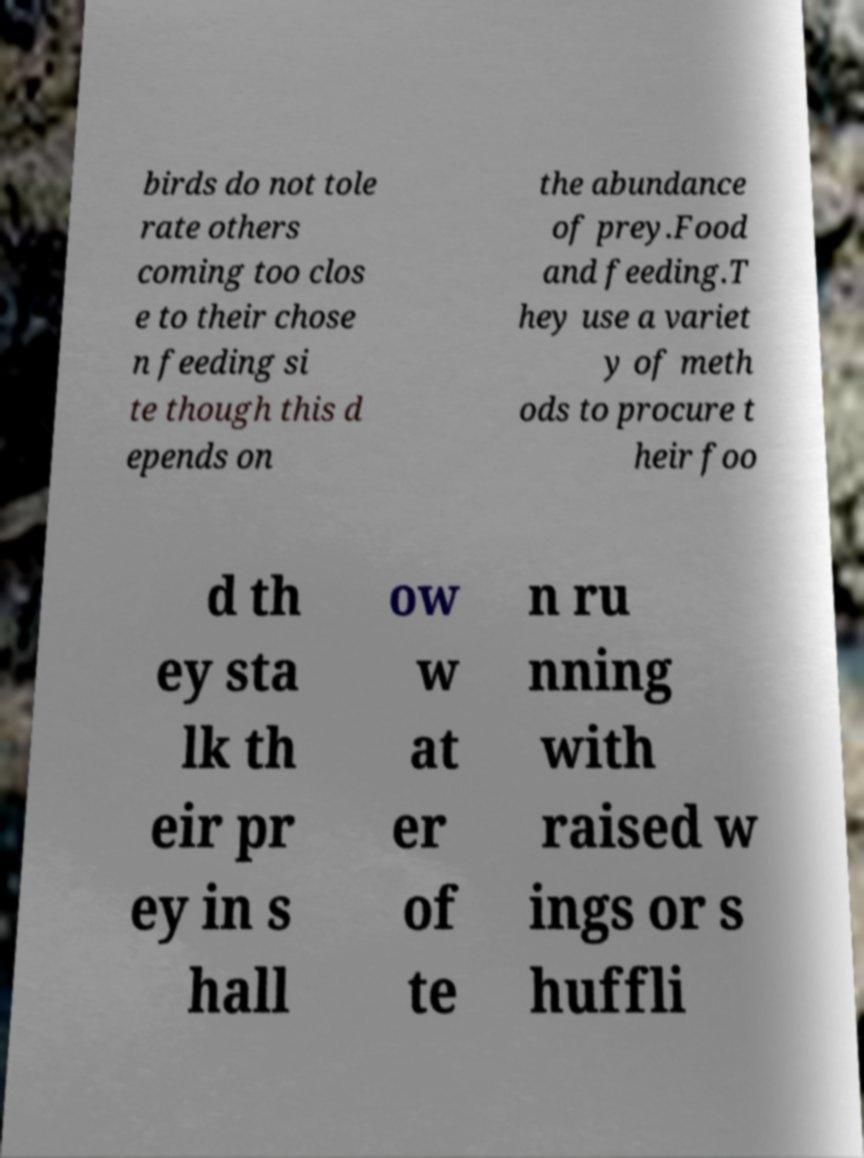Can you read and provide the text displayed in the image?This photo seems to have some interesting text. Can you extract and type it out for me? birds do not tole rate others coming too clos e to their chose n feeding si te though this d epends on the abundance of prey.Food and feeding.T hey use a variet y of meth ods to procure t heir foo d th ey sta lk th eir pr ey in s hall ow w at er of te n ru nning with raised w ings or s huffli 